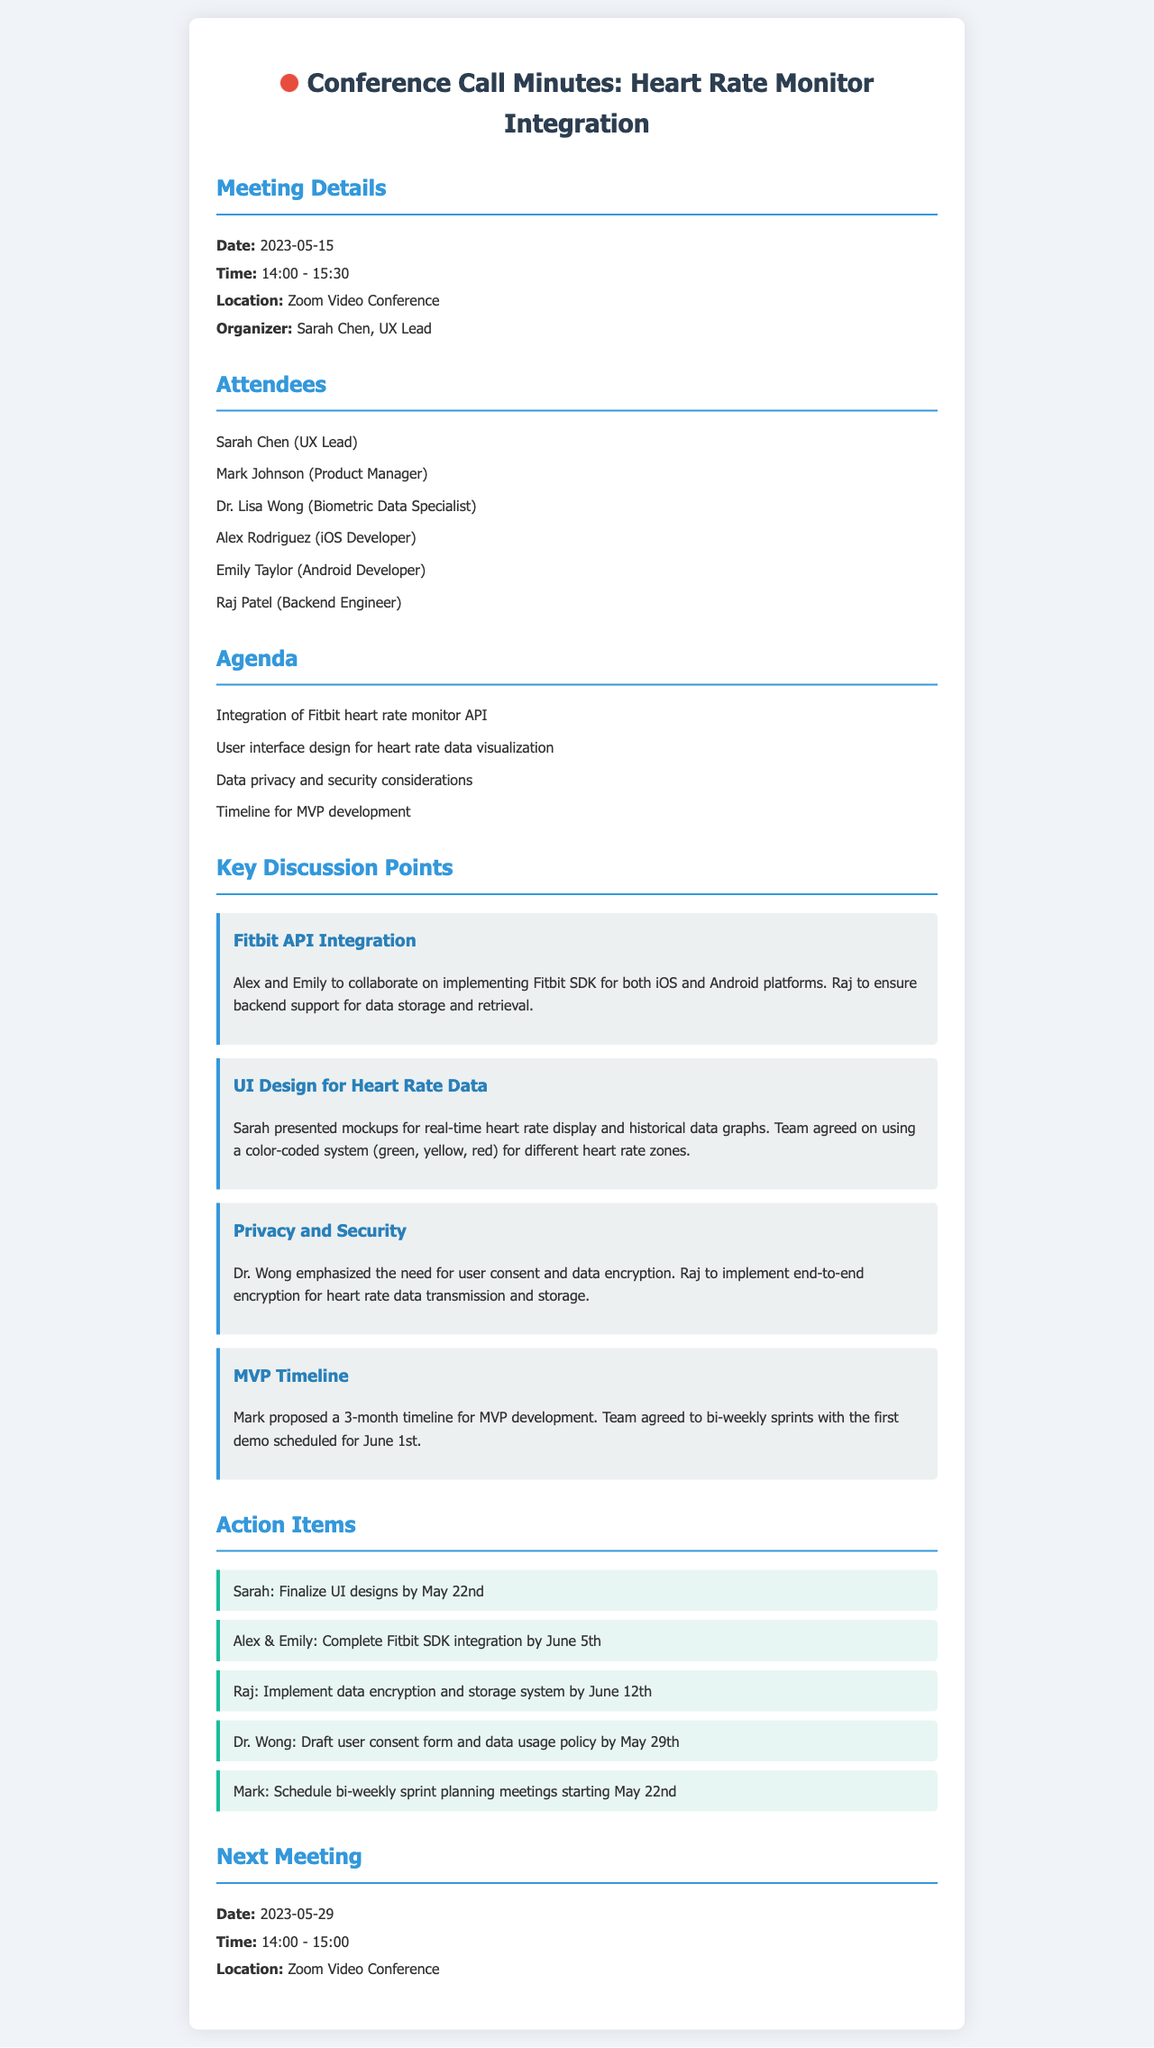what is the date of the meeting? The date of the meeting is clearly stated in the document under Meeting Details.
Answer: 2023-05-15 who is the organizer of the meeting? The organizer's name is included in the Meeting Details section.
Answer: Sarah Chen how long is the meeting scheduled for? The duration is mentioned in the Meeting Details section.
Answer: 1 hour 30 minutes what is the first agenda item? The agenda items are listed in the Agenda section, with the first item being the first entry.
Answer: Integration of Fitbit heart rate monitor API who is responsible for completing the Fitbit SDK integration? The discussion point mentions collaboration responsibilities among the attendees.
Answer: Alex & Emily what color system is agreed upon for heart rate zones? This information is discussed under the UI Design for Heart Rate Data bullet in the discussion section.
Answer: Color-coded system (green, yellow, red) when is the next meeting scheduled? The date of the next meeting is included in the Next Meeting section.
Answer: 2023-05-29 how many action items are listed? The action items are listed in the Action Items section; counting the items provides the answer.
Answer: 5 what is Raj's role in the meeting? Raj’s title is noted in the Attendees section.
Answer: Backend Engineer when is the first demo scheduled? The demo schedule is mentioned in the discussion about the MVP Timeline.
Answer: June 1st 